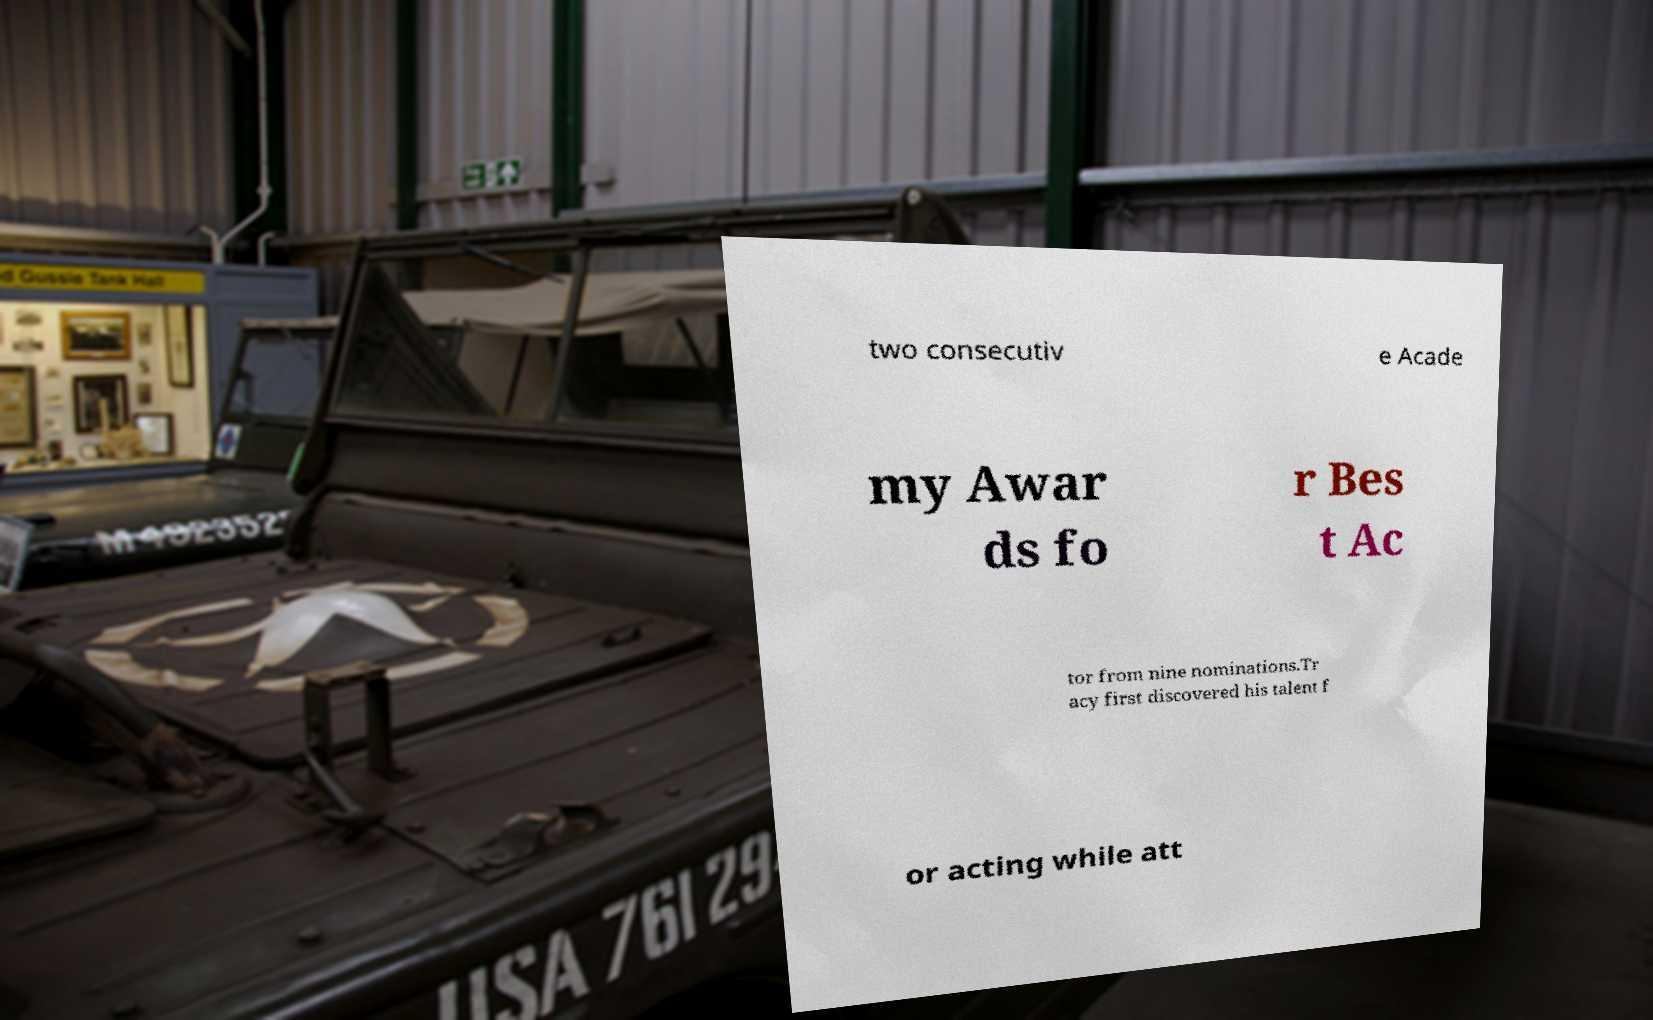Can you read and provide the text displayed in the image?This photo seems to have some interesting text. Can you extract and type it out for me? two consecutiv e Acade my Awar ds fo r Bes t Ac tor from nine nominations.Tr acy first discovered his talent f or acting while att 